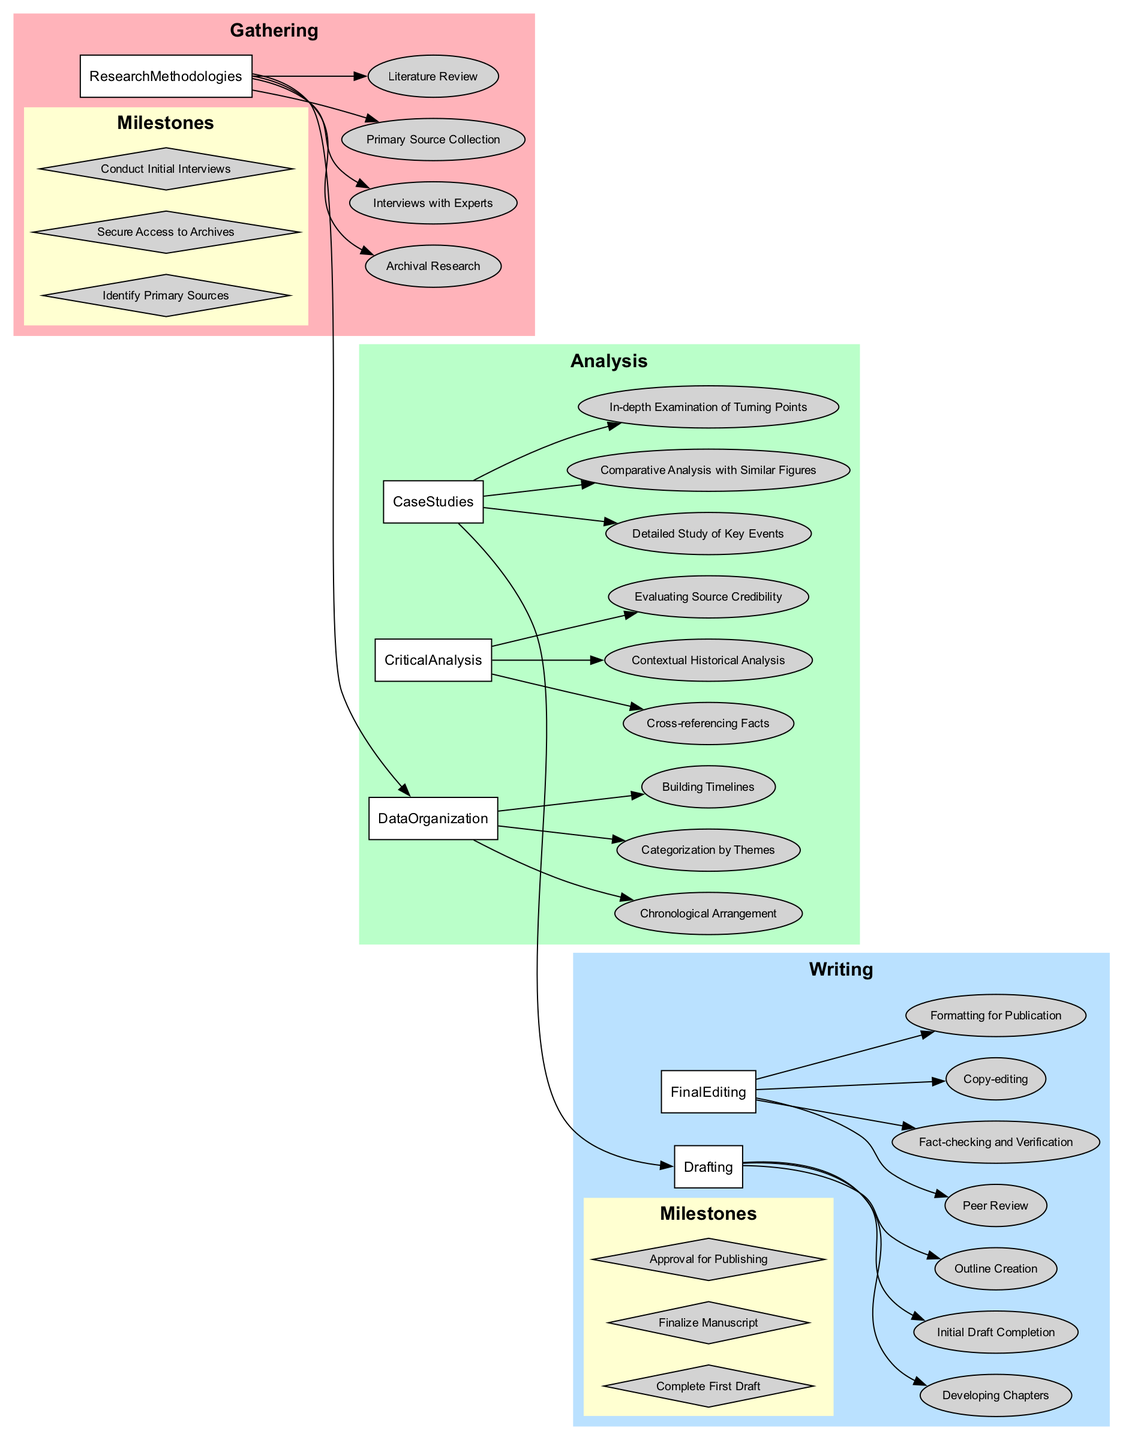What are the primary research methodologies in the Gathering phase? The Gathering phase lists four primary research methodologies: Archival Research, Interviews with Experts, Primary Source Collection, and Literature Review.
Answer: Archival Research, Interviews with Experts, Primary Source Collection, Literature Review How many data organization methods are present in the Analysis phase? The Analysis phase contains three methods for data organization: Chronological Arrangement, Categorization by Themes, and Building Timelines. Therefore, the total count is three.
Answer: 3 What is the final milestone in the Writing phase? Reviewing the Writing phase milestones, the last one listed is "Approval for Publishing." This indicates it is the final milestone.
Answer: Approval for Publishing Which two phases are directly connected by an edge? The diagram shows a direct connection or edge between "Gathering_ResearchMethodologies" and "Analysis_DataOrganization", indicating a flow from Gathering to Analysis.
Answer: Gathering and Analysis What type of analysis is included in the Analysis phase? The Analysis phase includes critical analysis types such as Cross-referencing Facts, Contextual Historical Analysis, and Evaluating Source Credibility. These are specified under Critical Analysis.
Answer: Critical Analysis How many milestones are listed in the Gathering phase? In the Gathering phase, there are three milestones: Identify Primary Sources, Secure Access to Archives, and Conduct Initial Interviews, indicating a total of three milestones listed under this phase.
Answer: 3 What follows after the Case Studies in the Analysis phase? After reviewing the flow, it is clear that the "Writing_Drafting" phase follows "Analysis_CaseStudies". This indicates the progression from analysis to the writing process after completing case studies.
Answer: Writing What is the shape of milestone nodes in the Writing phase? The milestones in the Writing phase are presented as diamond shapes in the diagram, distinguishing them from other nodes.
Answer: Diamond 